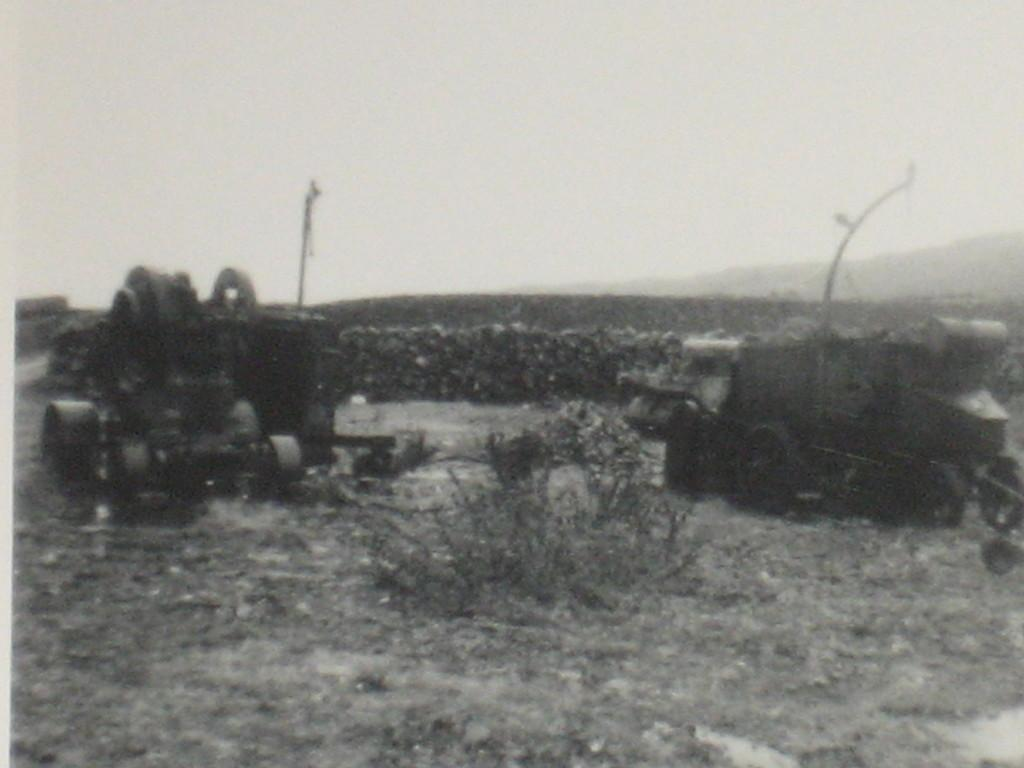What is the color scheme of the image? The image is black and white. What types of objects can be seen in the image? There are vehicles and poles in the image. What structures are present in the image? There is a wall in the image. What type of vegetation is visible in the image? There are plants in the image. What part of the natural environment is visible in the background of the image? The sky is visible in the background of the image. How many cacti can be seen in the image? There are no cacti present in the image. Can you describe the balancing act performed by the frogs in the image? There are no frogs present in the image, so there is no balancing act to describe. 